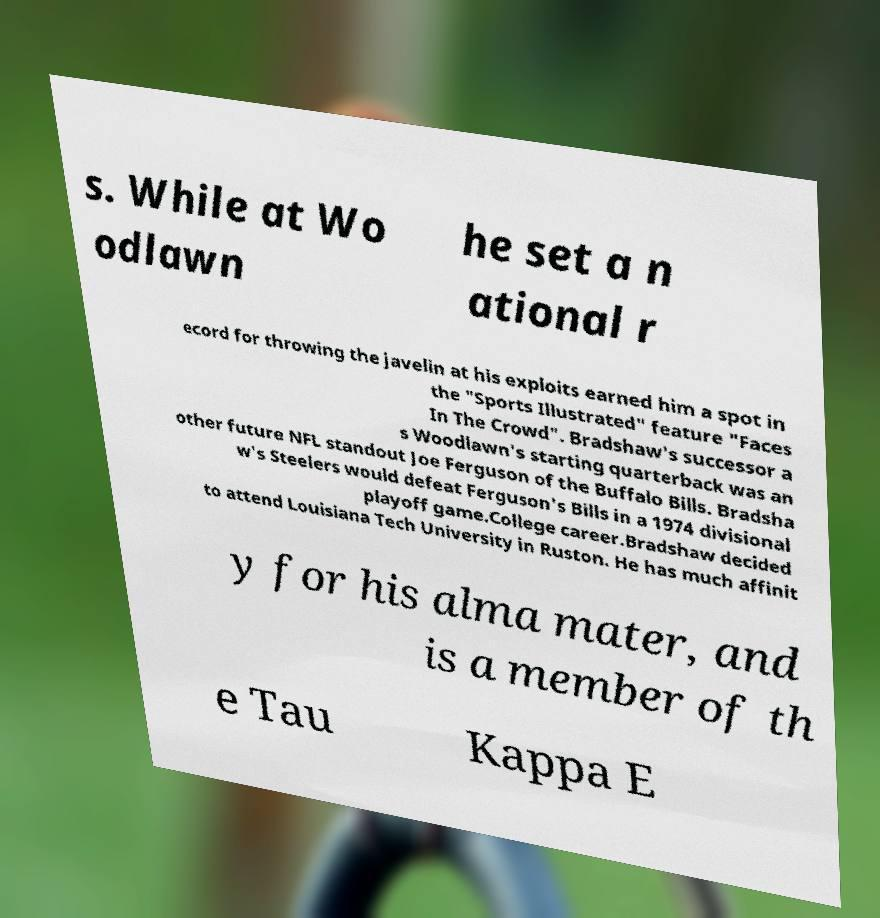Could you extract and type out the text from this image? s. While at Wo odlawn he set a n ational r ecord for throwing the javelin at his exploits earned him a spot in the "Sports Illustrated" feature "Faces In The Crowd". Bradshaw's successor a s Woodlawn's starting quarterback was an other future NFL standout Joe Ferguson of the Buffalo Bills. Bradsha w's Steelers would defeat Ferguson's Bills in a 1974 divisional playoff game.College career.Bradshaw decided to attend Louisiana Tech University in Ruston. He has much affinit y for his alma mater, and is a member of th e Tau Kappa E 